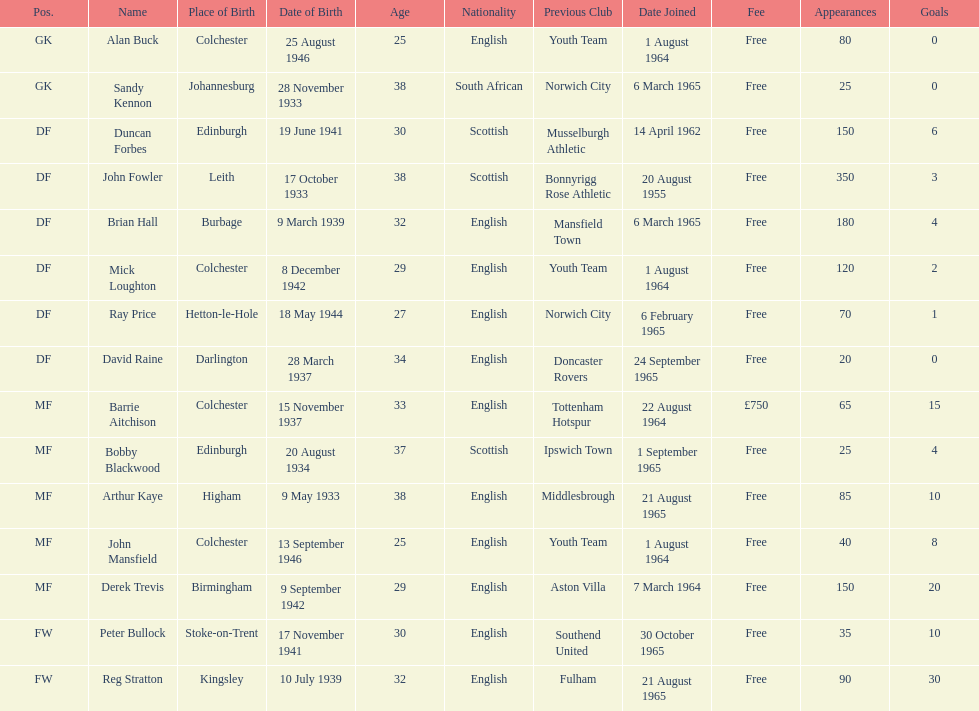Name the player whose fee was not free. Barrie Aitchison. 